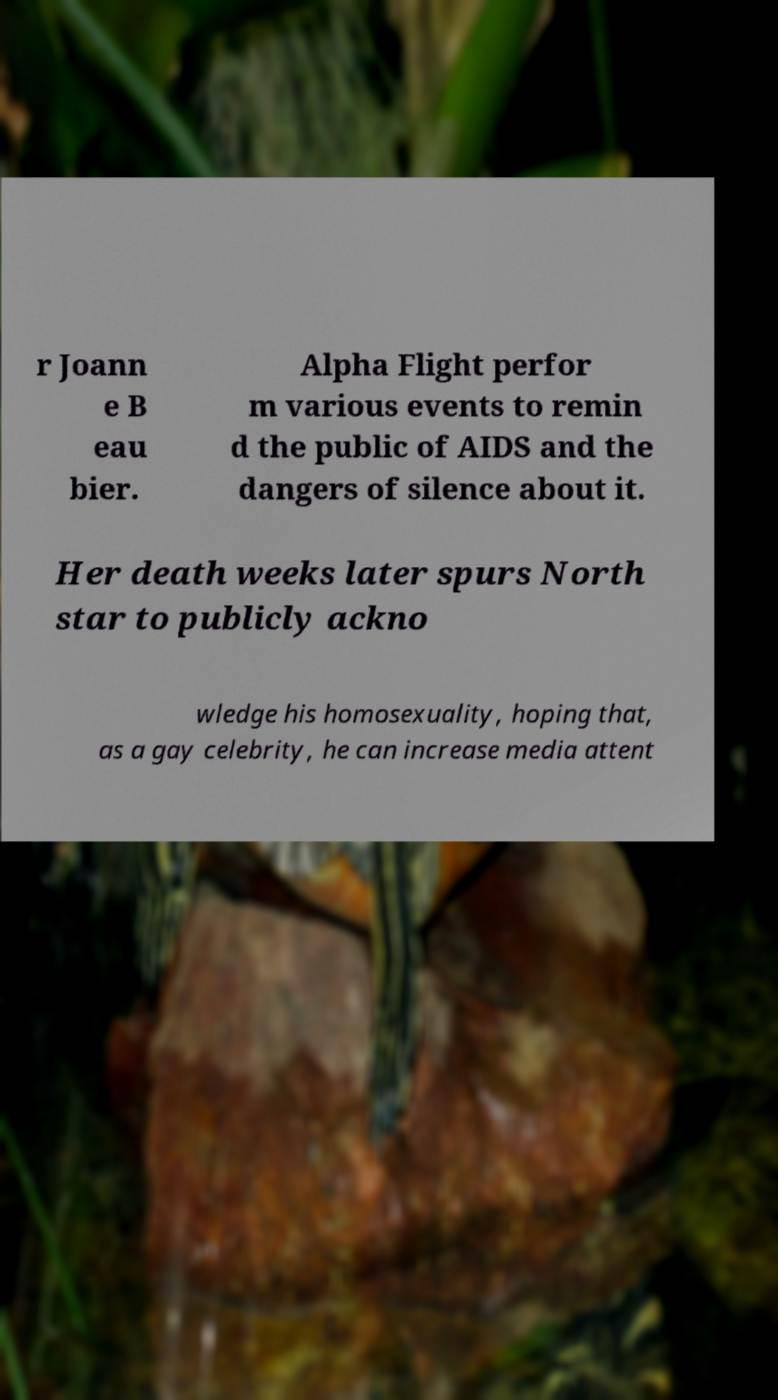For documentation purposes, I need the text within this image transcribed. Could you provide that? r Joann e B eau bier. Alpha Flight perfor m various events to remin d the public of AIDS and the dangers of silence about it. Her death weeks later spurs North star to publicly ackno wledge his homosexuality, hoping that, as a gay celebrity, he can increase media attent 